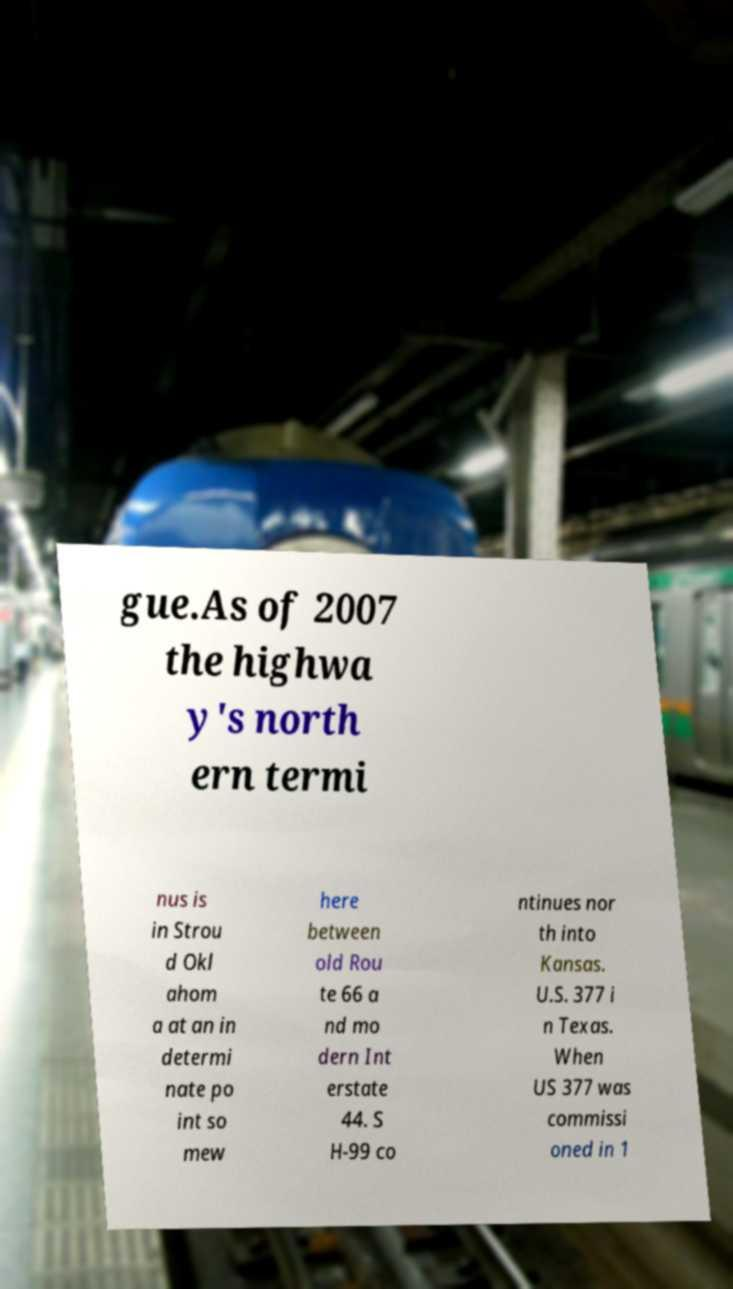I need the written content from this picture converted into text. Can you do that? gue.As of 2007 the highwa y's north ern termi nus is in Strou d Okl ahom a at an in determi nate po int so mew here between old Rou te 66 a nd mo dern Int erstate 44. S H-99 co ntinues nor th into Kansas. U.S. 377 i n Texas. When US 377 was commissi oned in 1 